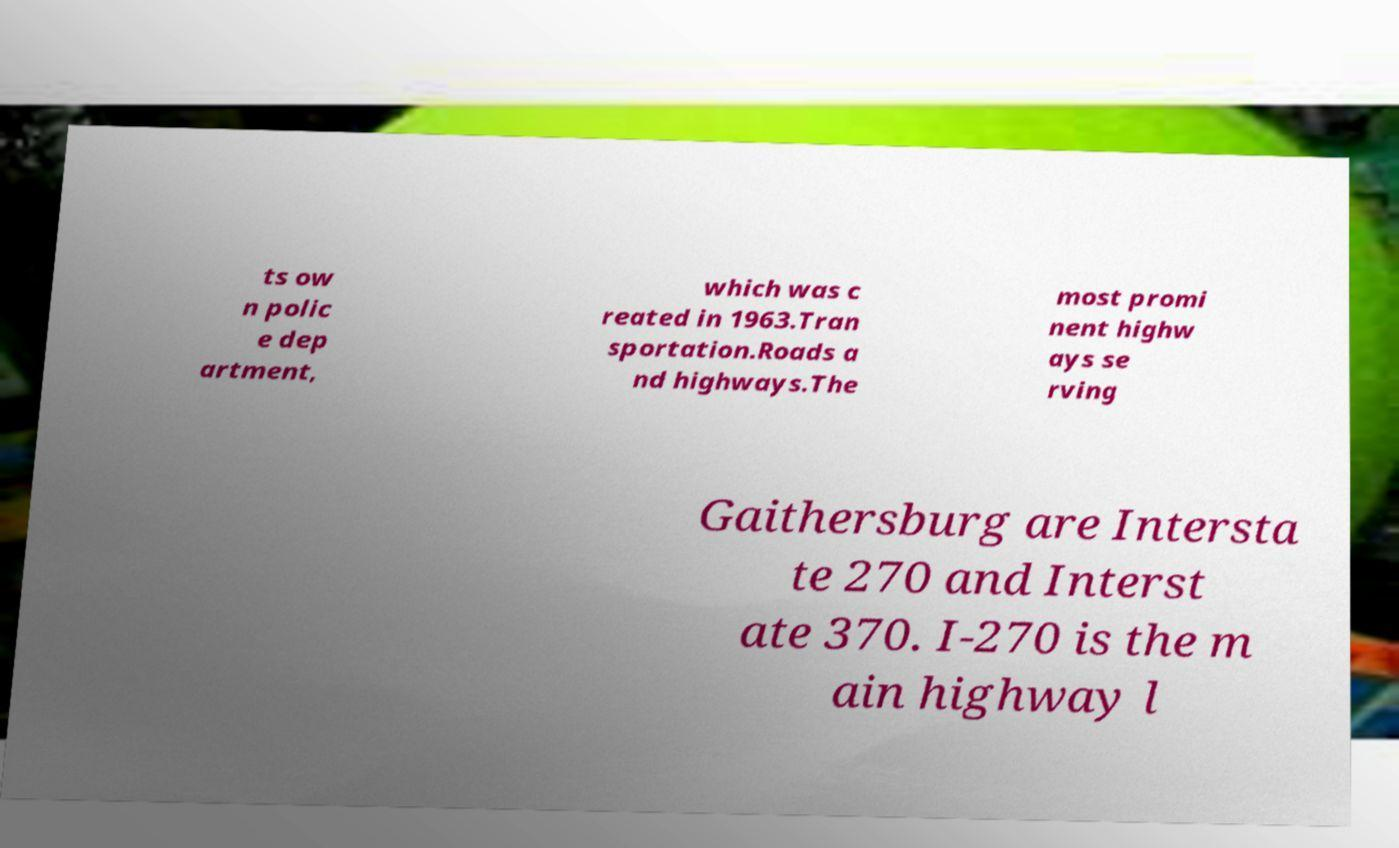What messages or text are displayed in this image? I need them in a readable, typed format. ts ow n polic e dep artment, which was c reated in 1963.Tran sportation.Roads a nd highways.The most promi nent highw ays se rving Gaithersburg are Intersta te 270 and Interst ate 370. I-270 is the m ain highway l 